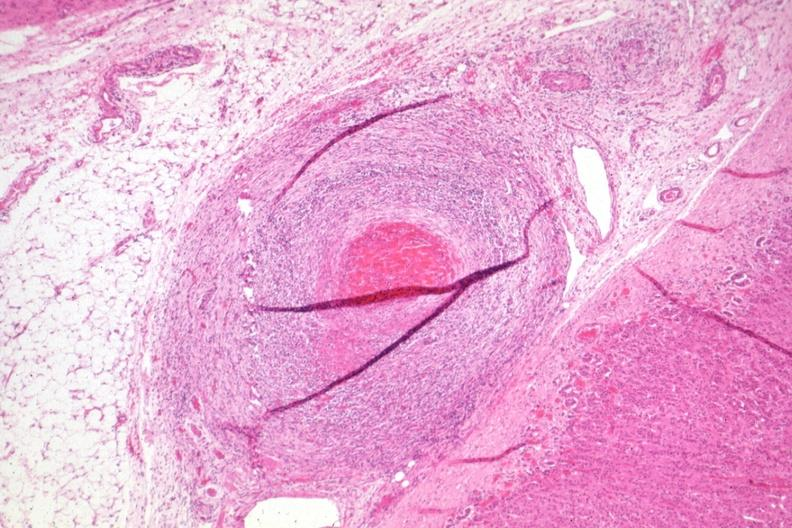s endocrine present?
Answer the question using a single word or phrase. Yes 